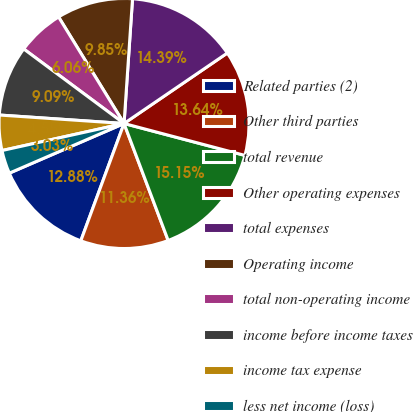<chart> <loc_0><loc_0><loc_500><loc_500><pie_chart><fcel>Related parties (2)<fcel>Other third parties<fcel>total revenue<fcel>Other operating expenses<fcel>total expenses<fcel>Operating income<fcel>total non-operating income<fcel>income before income taxes<fcel>income tax expense<fcel>less net income (loss)<nl><fcel>12.88%<fcel>11.36%<fcel>15.15%<fcel>13.64%<fcel>14.39%<fcel>9.85%<fcel>6.06%<fcel>9.09%<fcel>4.55%<fcel>3.03%<nl></chart> 